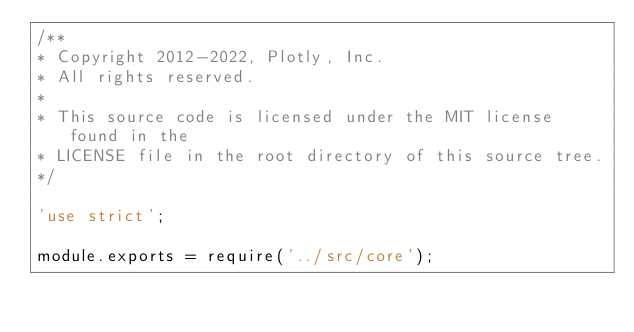<code> <loc_0><loc_0><loc_500><loc_500><_JavaScript_>/**
* Copyright 2012-2022, Plotly, Inc.
* All rights reserved.
*
* This source code is licensed under the MIT license found in the
* LICENSE file in the root directory of this source tree.
*/

'use strict';

module.exports = require('../src/core');
</code> 